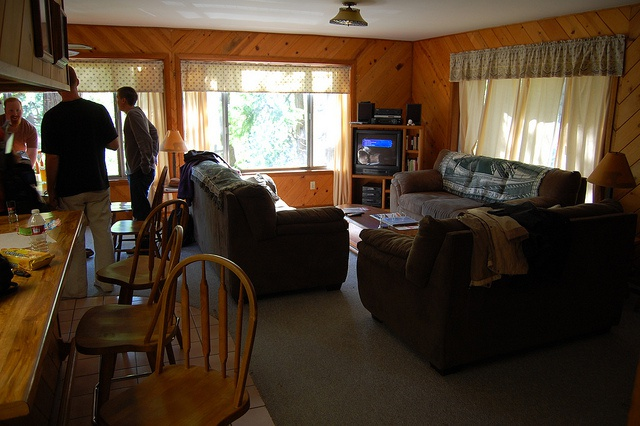Describe the objects in this image and their specific colors. I can see couch in black and gray tones, chair in black and maroon tones, dining table in black, maroon, and olive tones, couch in black, gray, and maroon tones, and couch in black and gray tones in this image. 